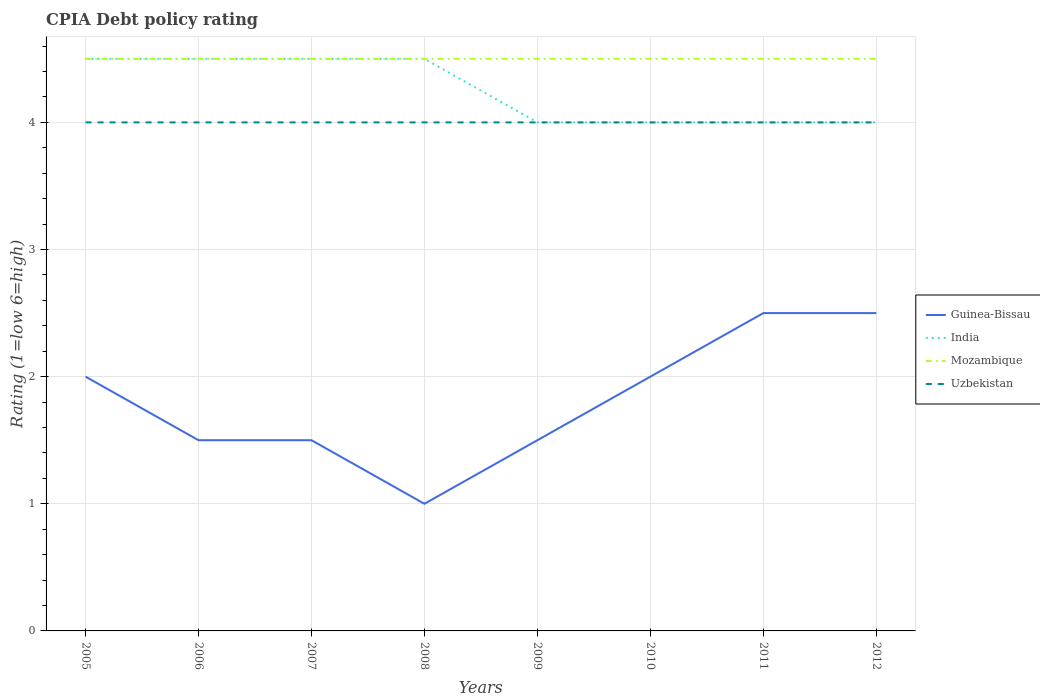Across all years, what is the maximum CPIA rating in Mozambique?
Keep it short and to the point. 4.5. In which year was the CPIA rating in Mozambique maximum?
Provide a succinct answer. 2005. What is the difference between the highest and the lowest CPIA rating in Guinea-Bissau?
Your answer should be compact. 4. Is the CPIA rating in Mozambique strictly greater than the CPIA rating in India over the years?
Your answer should be compact. No. How many lines are there?
Provide a succinct answer. 4. Does the graph contain any zero values?
Offer a very short reply. No. Where does the legend appear in the graph?
Your answer should be compact. Center right. How many legend labels are there?
Keep it short and to the point. 4. How are the legend labels stacked?
Give a very brief answer. Vertical. What is the title of the graph?
Keep it short and to the point. CPIA Debt policy rating. Does "Cuba" appear as one of the legend labels in the graph?
Provide a short and direct response. No. What is the label or title of the X-axis?
Keep it short and to the point. Years. What is the Rating (1=low 6=high) of India in 2005?
Your response must be concise. 4.5. What is the Rating (1=low 6=high) of India in 2007?
Your response must be concise. 4.5. What is the Rating (1=low 6=high) in Guinea-Bissau in 2008?
Make the answer very short. 1. What is the Rating (1=low 6=high) in India in 2008?
Offer a terse response. 4.5. What is the Rating (1=low 6=high) in Uzbekistan in 2008?
Make the answer very short. 4. What is the Rating (1=low 6=high) in India in 2009?
Your response must be concise. 4. What is the Rating (1=low 6=high) in Uzbekistan in 2009?
Provide a succinct answer. 4. What is the Rating (1=low 6=high) of Guinea-Bissau in 2010?
Keep it short and to the point. 2. What is the Rating (1=low 6=high) in India in 2010?
Offer a very short reply. 4. What is the Rating (1=low 6=high) of Uzbekistan in 2010?
Your response must be concise. 4. What is the Rating (1=low 6=high) of Guinea-Bissau in 2012?
Offer a very short reply. 2.5. Across all years, what is the maximum Rating (1=low 6=high) in Guinea-Bissau?
Your response must be concise. 2.5. Across all years, what is the maximum Rating (1=low 6=high) of Mozambique?
Your answer should be very brief. 4.5. Across all years, what is the maximum Rating (1=low 6=high) of Uzbekistan?
Offer a very short reply. 4. Across all years, what is the minimum Rating (1=low 6=high) of Guinea-Bissau?
Provide a short and direct response. 1. Across all years, what is the minimum Rating (1=low 6=high) in Mozambique?
Offer a terse response. 4.5. Across all years, what is the minimum Rating (1=low 6=high) of Uzbekistan?
Provide a short and direct response. 4. What is the total Rating (1=low 6=high) of Uzbekistan in the graph?
Ensure brevity in your answer.  32. What is the difference between the Rating (1=low 6=high) of India in 2005 and that in 2007?
Offer a very short reply. 0. What is the difference between the Rating (1=low 6=high) of Guinea-Bissau in 2005 and that in 2008?
Make the answer very short. 1. What is the difference between the Rating (1=low 6=high) of India in 2005 and that in 2008?
Offer a terse response. 0. What is the difference between the Rating (1=low 6=high) in Uzbekistan in 2005 and that in 2008?
Offer a very short reply. 0. What is the difference between the Rating (1=low 6=high) in Guinea-Bissau in 2005 and that in 2009?
Your answer should be compact. 0.5. What is the difference between the Rating (1=low 6=high) of India in 2005 and that in 2009?
Offer a terse response. 0.5. What is the difference between the Rating (1=low 6=high) in Uzbekistan in 2005 and that in 2009?
Provide a short and direct response. 0. What is the difference between the Rating (1=low 6=high) in Guinea-Bissau in 2005 and that in 2010?
Your response must be concise. 0. What is the difference between the Rating (1=low 6=high) in India in 2005 and that in 2010?
Give a very brief answer. 0.5. What is the difference between the Rating (1=low 6=high) of Uzbekistan in 2005 and that in 2010?
Make the answer very short. 0. What is the difference between the Rating (1=low 6=high) in Guinea-Bissau in 2005 and that in 2011?
Keep it short and to the point. -0.5. What is the difference between the Rating (1=low 6=high) of India in 2005 and that in 2011?
Make the answer very short. 0.5. What is the difference between the Rating (1=low 6=high) in Mozambique in 2005 and that in 2012?
Keep it short and to the point. 0. What is the difference between the Rating (1=low 6=high) in Guinea-Bissau in 2006 and that in 2007?
Ensure brevity in your answer.  0. What is the difference between the Rating (1=low 6=high) in Mozambique in 2006 and that in 2007?
Make the answer very short. 0. What is the difference between the Rating (1=low 6=high) of Guinea-Bissau in 2006 and that in 2008?
Offer a terse response. 0.5. What is the difference between the Rating (1=low 6=high) of Mozambique in 2006 and that in 2008?
Keep it short and to the point. 0. What is the difference between the Rating (1=low 6=high) of India in 2006 and that in 2009?
Your response must be concise. 0.5. What is the difference between the Rating (1=low 6=high) of Guinea-Bissau in 2006 and that in 2010?
Offer a terse response. -0.5. What is the difference between the Rating (1=low 6=high) of Mozambique in 2006 and that in 2010?
Your response must be concise. 0. What is the difference between the Rating (1=low 6=high) of Uzbekistan in 2006 and that in 2010?
Your response must be concise. 0. What is the difference between the Rating (1=low 6=high) in India in 2006 and that in 2011?
Keep it short and to the point. 0.5. What is the difference between the Rating (1=low 6=high) of Guinea-Bissau in 2006 and that in 2012?
Provide a succinct answer. -1. What is the difference between the Rating (1=low 6=high) of India in 2006 and that in 2012?
Provide a succinct answer. 0.5. What is the difference between the Rating (1=low 6=high) of Uzbekistan in 2006 and that in 2012?
Provide a short and direct response. 0. What is the difference between the Rating (1=low 6=high) in Mozambique in 2007 and that in 2008?
Your answer should be very brief. 0. What is the difference between the Rating (1=low 6=high) of Guinea-Bissau in 2007 and that in 2009?
Offer a very short reply. 0. What is the difference between the Rating (1=low 6=high) in India in 2007 and that in 2009?
Your answer should be compact. 0.5. What is the difference between the Rating (1=low 6=high) of Mozambique in 2007 and that in 2009?
Keep it short and to the point. 0. What is the difference between the Rating (1=low 6=high) of Uzbekistan in 2007 and that in 2009?
Ensure brevity in your answer.  0. What is the difference between the Rating (1=low 6=high) of Guinea-Bissau in 2007 and that in 2010?
Your response must be concise. -0.5. What is the difference between the Rating (1=low 6=high) of India in 2007 and that in 2010?
Give a very brief answer. 0.5. What is the difference between the Rating (1=low 6=high) of Uzbekistan in 2007 and that in 2010?
Provide a succinct answer. 0. What is the difference between the Rating (1=low 6=high) of India in 2007 and that in 2011?
Provide a short and direct response. 0.5. What is the difference between the Rating (1=low 6=high) in Guinea-Bissau in 2007 and that in 2012?
Ensure brevity in your answer.  -1. What is the difference between the Rating (1=low 6=high) of Mozambique in 2007 and that in 2012?
Offer a very short reply. 0. What is the difference between the Rating (1=low 6=high) of Uzbekistan in 2007 and that in 2012?
Your answer should be very brief. 0. What is the difference between the Rating (1=low 6=high) of Mozambique in 2008 and that in 2009?
Offer a very short reply. 0. What is the difference between the Rating (1=low 6=high) of India in 2008 and that in 2010?
Give a very brief answer. 0.5. What is the difference between the Rating (1=low 6=high) of Uzbekistan in 2008 and that in 2010?
Provide a succinct answer. 0. What is the difference between the Rating (1=low 6=high) of Guinea-Bissau in 2008 and that in 2011?
Your answer should be compact. -1.5. What is the difference between the Rating (1=low 6=high) of India in 2008 and that in 2011?
Provide a short and direct response. 0.5. What is the difference between the Rating (1=low 6=high) of Uzbekistan in 2008 and that in 2011?
Provide a succinct answer. 0. What is the difference between the Rating (1=low 6=high) in India in 2008 and that in 2012?
Provide a succinct answer. 0.5. What is the difference between the Rating (1=low 6=high) of Mozambique in 2008 and that in 2012?
Your response must be concise. 0. What is the difference between the Rating (1=low 6=high) in Uzbekistan in 2008 and that in 2012?
Your answer should be compact. 0. What is the difference between the Rating (1=low 6=high) of Guinea-Bissau in 2009 and that in 2010?
Your response must be concise. -0.5. What is the difference between the Rating (1=low 6=high) of India in 2009 and that in 2010?
Make the answer very short. 0. What is the difference between the Rating (1=low 6=high) of Mozambique in 2009 and that in 2010?
Provide a short and direct response. 0. What is the difference between the Rating (1=low 6=high) in Uzbekistan in 2009 and that in 2010?
Offer a very short reply. 0. What is the difference between the Rating (1=low 6=high) in Guinea-Bissau in 2009 and that in 2011?
Your response must be concise. -1. What is the difference between the Rating (1=low 6=high) of India in 2009 and that in 2011?
Provide a short and direct response. 0. What is the difference between the Rating (1=low 6=high) in Uzbekistan in 2009 and that in 2011?
Give a very brief answer. 0. What is the difference between the Rating (1=low 6=high) of Guinea-Bissau in 2009 and that in 2012?
Provide a short and direct response. -1. What is the difference between the Rating (1=low 6=high) in Mozambique in 2009 and that in 2012?
Your answer should be compact. 0. What is the difference between the Rating (1=low 6=high) in India in 2010 and that in 2011?
Make the answer very short. 0. What is the difference between the Rating (1=low 6=high) in Mozambique in 2010 and that in 2011?
Offer a very short reply. 0. What is the difference between the Rating (1=low 6=high) in India in 2011 and that in 2012?
Provide a short and direct response. 0. What is the difference between the Rating (1=low 6=high) of Guinea-Bissau in 2005 and the Rating (1=low 6=high) of Mozambique in 2006?
Provide a short and direct response. -2.5. What is the difference between the Rating (1=low 6=high) of Mozambique in 2005 and the Rating (1=low 6=high) of Uzbekistan in 2006?
Give a very brief answer. 0.5. What is the difference between the Rating (1=low 6=high) of Guinea-Bissau in 2005 and the Rating (1=low 6=high) of India in 2007?
Your answer should be compact. -2.5. What is the difference between the Rating (1=low 6=high) in Guinea-Bissau in 2005 and the Rating (1=low 6=high) in Uzbekistan in 2007?
Keep it short and to the point. -2. What is the difference between the Rating (1=low 6=high) of India in 2005 and the Rating (1=low 6=high) of Uzbekistan in 2007?
Give a very brief answer. 0.5. What is the difference between the Rating (1=low 6=high) of Guinea-Bissau in 2005 and the Rating (1=low 6=high) of India in 2008?
Offer a very short reply. -2.5. What is the difference between the Rating (1=low 6=high) in Guinea-Bissau in 2005 and the Rating (1=low 6=high) in Mozambique in 2008?
Provide a succinct answer. -2.5. What is the difference between the Rating (1=low 6=high) in India in 2005 and the Rating (1=low 6=high) in Mozambique in 2008?
Your response must be concise. 0. What is the difference between the Rating (1=low 6=high) of India in 2005 and the Rating (1=low 6=high) of Uzbekistan in 2008?
Make the answer very short. 0.5. What is the difference between the Rating (1=low 6=high) of Guinea-Bissau in 2005 and the Rating (1=low 6=high) of India in 2009?
Provide a short and direct response. -2. What is the difference between the Rating (1=low 6=high) in Guinea-Bissau in 2005 and the Rating (1=low 6=high) in Uzbekistan in 2009?
Provide a short and direct response. -2. What is the difference between the Rating (1=low 6=high) in Guinea-Bissau in 2005 and the Rating (1=low 6=high) in India in 2010?
Offer a terse response. -2. What is the difference between the Rating (1=low 6=high) in Guinea-Bissau in 2005 and the Rating (1=low 6=high) in Mozambique in 2010?
Your response must be concise. -2.5. What is the difference between the Rating (1=low 6=high) in India in 2005 and the Rating (1=low 6=high) in Uzbekistan in 2010?
Your answer should be compact. 0.5. What is the difference between the Rating (1=low 6=high) in Guinea-Bissau in 2005 and the Rating (1=low 6=high) in India in 2011?
Offer a terse response. -2. What is the difference between the Rating (1=low 6=high) in India in 2005 and the Rating (1=low 6=high) in Uzbekistan in 2011?
Provide a short and direct response. 0.5. What is the difference between the Rating (1=low 6=high) of Mozambique in 2005 and the Rating (1=low 6=high) of Uzbekistan in 2011?
Offer a terse response. 0.5. What is the difference between the Rating (1=low 6=high) in Guinea-Bissau in 2005 and the Rating (1=low 6=high) in Mozambique in 2012?
Your response must be concise. -2.5. What is the difference between the Rating (1=low 6=high) in Mozambique in 2005 and the Rating (1=low 6=high) in Uzbekistan in 2012?
Your answer should be compact. 0.5. What is the difference between the Rating (1=low 6=high) of Guinea-Bissau in 2006 and the Rating (1=low 6=high) of Uzbekistan in 2007?
Ensure brevity in your answer.  -2.5. What is the difference between the Rating (1=low 6=high) of Mozambique in 2006 and the Rating (1=low 6=high) of Uzbekistan in 2007?
Provide a short and direct response. 0.5. What is the difference between the Rating (1=low 6=high) in Guinea-Bissau in 2006 and the Rating (1=low 6=high) in India in 2008?
Give a very brief answer. -3. What is the difference between the Rating (1=low 6=high) in Guinea-Bissau in 2006 and the Rating (1=low 6=high) in Mozambique in 2008?
Ensure brevity in your answer.  -3. What is the difference between the Rating (1=low 6=high) in Mozambique in 2006 and the Rating (1=low 6=high) in Uzbekistan in 2008?
Give a very brief answer. 0.5. What is the difference between the Rating (1=low 6=high) of Guinea-Bissau in 2006 and the Rating (1=low 6=high) of India in 2009?
Keep it short and to the point. -2.5. What is the difference between the Rating (1=low 6=high) of Guinea-Bissau in 2006 and the Rating (1=low 6=high) of Uzbekistan in 2009?
Your response must be concise. -2.5. What is the difference between the Rating (1=low 6=high) of India in 2006 and the Rating (1=low 6=high) of Mozambique in 2009?
Offer a very short reply. 0. What is the difference between the Rating (1=low 6=high) in Guinea-Bissau in 2006 and the Rating (1=low 6=high) in Mozambique in 2010?
Offer a terse response. -3. What is the difference between the Rating (1=low 6=high) of Guinea-Bissau in 2006 and the Rating (1=low 6=high) of Uzbekistan in 2010?
Provide a short and direct response. -2.5. What is the difference between the Rating (1=low 6=high) of India in 2006 and the Rating (1=low 6=high) of Mozambique in 2010?
Provide a short and direct response. 0. What is the difference between the Rating (1=low 6=high) of Mozambique in 2006 and the Rating (1=low 6=high) of Uzbekistan in 2010?
Provide a short and direct response. 0.5. What is the difference between the Rating (1=low 6=high) in Guinea-Bissau in 2006 and the Rating (1=low 6=high) in India in 2011?
Your response must be concise. -2.5. What is the difference between the Rating (1=low 6=high) in India in 2006 and the Rating (1=low 6=high) in Uzbekistan in 2011?
Your answer should be very brief. 0.5. What is the difference between the Rating (1=low 6=high) of Mozambique in 2006 and the Rating (1=low 6=high) of Uzbekistan in 2011?
Provide a short and direct response. 0.5. What is the difference between the Rating (1=low 6=high) of Guinea-Bissau in 2006 and the Rating (1=low 6=high) of Mozambique in 2012?
Provide a succinct answer. -3. What is the difference between the Rating (1=low 6=high) in Guinea-Bissau in 2006 and the Rating (1=low 6=high) in Uzbekistan in 2012?
Provide a succinct answer. -2.5. What is the difference between the Rating (1=low 6=high) of Mozambique in 2006 and the Rating (1=low 6=high) of Uzbekistan in 2012?
Give a very brief answer. 0.5. What is the difference between the Rating (1=low 6=high) in Guinea-Bissau in 2007 and the Rating (1=low 6=high) in India in 2008?
Your answer should be very brief. -3. What is the difference between the Rating (1=low 6=high) in Guinea-Bissau in 2007 and the Rating (1=low 6=high) in Uzbekistan in 2008?
Provide a succinct answer. -2.5. What is the difference between the Rating (1=low 6=high) of India in 2007 and the Rating (1=low 6=high) of Mozambique in 2008?
Your response must be concise. 0. What is the difference between the Rating (1=low 6=high) of Guinea-Bissau in 2007 and the Rating (1=low 6=high) of Mozambique in 2009?
Your answer should be compact. -3. What is the difference between the Rating (1=low 6=high) in India in 2007 and the Rating (1=low 6=high) in Uzbekistan in 2009?
Provide a short and direct response. 0.5. What is the difference between the Rating (1=low 6=high) in Guinea-Bissau in 2007 and the Rating (1=low 6=high) in India in 2010?
Ensure brevity in your answer.  -2.5. What is the difference between the Rating (1=low 6=high) of India in 2007 and the Rating (1=low 6=high) of Mozambique in 2010?
Offer a terse response. 0. What is the difference between the Rating (1=low 6=high) of India in 2007 and the Rating (1=low 6=high) of Uzbekistan in 2010?
Your response must be concise. 0.5. What is the difference between the Rating (1=low 6=high) of Mozambique in 2007 and the Rating (1=low 6=high) of Uzbekistan in 2010?
Make the answer very short. 0.5. What is the difference between the Rating (1=low 6=high) of India in 2007 and the Rating (1=low 6=high) of Mozambique in 2011?
Ensure brevity in your answer.  0. What is the difference between the Rating (1=low 6=high) in Mozambique in 2007 and the Rating (1=low 6=high) in Uzbekistan in 2011?
Keep it short and to the point. 0.5. What is the difference between the Rating (1=low 6=high) of Guinea-Bissau in 2007 and the Rating (1=low 6=high) of Uzbekistan in 2012?
Provide a short and direct response. -2.5. What is the difference between the Rating (1=low 6=high) in India in 2007 and the Rating (1=low 6=high) in Mozambique in 2012?
Your response must be concise. 0. What is the difference between the Rating (1=low 6=high) of Mozambique in 2007 and the Rating (1=low 6=high) of Uzbekistan in 2012?
Your response must be concise. 0.5. What is the difference between the Rating (1=low 6=high) in Guinea-Bissau in 2008 and the Rating (1=low 6=high) in Uzbekistan in 2009?
Your answer should be very brief. -3. What is the difference between the Rating (1=low 6=high) of India in 2008 and the Rating (1=low 6=high) of Uzbekistan in 2009?
Your answer should be compact. 0.5. What is the difference between the Rating (1=low 6=high) of Mozambique in 2008 and the Rating (1=low 6=high) of Uzbekistan in 2009?
Ensure brevity in your answer.  0.5. What is the difference between the Rating (1=low 6=high) of Guinea-Bissau in 2008 and the Rating (1=low 6=high) of India in 2010?
Your answer should be compact. -3. What is the difference between the Rating (1=low 6=high) in Guinea-Bissau in 2008 and the Rating (1=low 6=high) in Uzbekistan in 2010?
Make the answer very short. -3. What is the difference between the Rating (1=low 6=high) in India in 2008 and the Rating (1=low 6=high) in Mozambique in 2010?
Provide a short and direct response. 0. What is the difference between the Rating (1=low 6=high) in India in 2008 and the Rating (1=low 6=high) in Uzbekistan in 2010?
Provide a succinct answer. 0.5. What is the difference between the Rating (1=low 6=high) of Guinea-Bissau in 2008 and the Rating (1=low 6=high) of Uzbekistan in 2011?
Make the answer very short. -3. What is the difference between the Rating (1=low 6=high) in India in 2008 and the Rating (1=low 6=high) in Uzbekistan in 2011?
Offer a terse response. 0.5. What is the difference between the Rating (1=low 6=high) of Mozambique in 2008 and the Rating (1=low 6=high) of Uzbekistan in 2011?
Give a very brief answer. 0.5. What is the difference between the Rating (1=low 6=high) in Guinea-Bissau in 2008 and the Rating (1=low 6=high) in India in 2012?
Keep it short and to the point. -3. What is the difference between the Rating (1=low 6=high) in India in 2008 and the Rating (1=low 6=high) in Uzbekistan in 2012?
Keep it short and to the point. 0.5. What is the difference between the Rating (1=low 6=high) of Mozambique in 2008 and the Rating (1=low 6=high) of Uzbekistan in 2012?
Provide a succinct answer. 0.5. What is the difference between the Rating (1=low 6=high) of Guinea-Bissau in 2009 and the Rating (1=low 6=high) of India in 2010?
Make the answer very short. -2.5. What is the difference between the Rating (1=low 6=high) in Guinea-Bissau in 2009 and the Rating (1=low 6=high) in Mozambique in 2010?
Give a very brief answer. -3. What is the difference between the Rating (1=low 6=high) of Guinea-Bissau in 2009 and the Rating (1=low 6=high) of Uzbekistan in 2010?
Your answer should be compact. -2.5. What is the difference between the Rating (1=low 6=high) of Guinea-Bissau in 2009 and the Rating (1=low 6=high) of Mozambique in 2011?
Offer a terse response. -3. What is the difference between the Rating (1=low 6=high) of India in 2009 and the Rating (1=low 6=high) of Mozambique in 2011?
Offer a terse response. -0.5. What is the difference between the Rating (1=low 6=high) of India in 2009 and the Rating (1=low 6=high) of Uzbekistan in 2011?
Make the answer very short. 0. What is the difference between the Rating (1=low 6=high) of Guinea-Bissau in 2009 and the Rating (1=low 6=high) of India in 2012?
Ensure brevity in your answer.  -2.5. What is the difference between the Rating (1=low 6=high) in Guinea-Bissau in 2009 and the Rating (1=low 6=high) in Uzbekistan in 2012?
Ensure brevity in your answer.  -2.5. What is the difference between the Rating (1=low 6=high) in India in 2009 and the Rating (1=low 6=high) in Mozambique in 2012?
Offer a terse response. -0.5. What is the difference between the Rating (1=low 6=high) in India in 2010 and the Rating (1=low 6=high) in Mozambique in 2011?
Make the answer very short. -0.5. What is the difference between the Rating (1=low 6=high) in Mozambique in 2010 and the Rating (1=low 6=high) in Uzbekistan in 2011?
Offer a very short reply. 0.5. What is the difference between the Rating (1=low 6=high) in Guinea-Bissau in 2010 and the Rating (1=low 6=high) in Mozambique in 2012?
Offer a very short reply. -2.5. What is the difference between the Rating (1=low 6=high) of Mozambique in 2010 and the Rating (1=low 6=high) of Uzbekistan in 2012?
Offer a very short reply. 0.5. What is the difference between the Rating (1=low 6=high) in Guinea-Bissau in 2011 and the Rating (1=low 6=high) in Mozambique in 2012?
Your response must be concise. -2. What is the difference between the Rating (1=low 6=high) in Mozambique in 2011 and the Rating (1=low 6=high) in Uzbekistan in 2012?
Give a very brief answer. 0.5. What is the average Rating (1=low 6=high) of Guinea-Bissau per year?
Make the answer very short. 1.81. What is the average Rating (1=low 6=high) of India per year?
Ensure brevity in your answer.  4.25. In the year 2005, what is the difference between the Rating (1=low 6=high) of Guinea-Bissau and Rating (1=low 6=high) of India?
Your response must be concise. -2.5. In the year 2005, what is the difference between the Rating (1=low 6=high) of Guinea-Bissau and Rating (1=low 6=high) of Mozambique?
Give a very brief answer. -2.5. In the year 2005, what is the difference between the Rating (1=low 6=high) of Guinea-Bissau and Rating (1=low 6=high) of Uzbekistan?
Provide a succinct answer. -2. In the year 2005, what is the difference between the Rating (1=low 6=high) in India and Rating (1=low 6=high) in Uzbekistan?
Make the answer very short. 0.5. In the year 2005, what is the difference between the Rating (1=low 6=high) in Mozambique and Rating (1=low 6=high) in Uzbekistan?
Keep it short and to the point. 0.5. In the year 2006, what is the difference between the Rating (1=low 6=high) in Guinea-Bissau and Rating (1=low 6=high) in Mozambique?
Your response must be concise. -3. In the year 2006, what is the difference between the Rating (1=low 6=high) in India and Rating (1=low 6=high) in Uzbekistan?
Provide a succinct answer. 0.5. In the year 2006, what is the difference between the Rating (1=low 6=high) in Mozambique and Rating (1=low 6=high) in Uzbekistan?
Provide a short and direct response. 0.5. In the year 2007, what is the difference between the Rating (1=low 6=high) of Mozambique and Rating (1=low 6=high) of Uzbekistan?
Your response must be concise. 0.5. In the year 2008, what is the difference between the Rating (1=low 6=high) of India and Rating (1=low 6=high) of Uzbekistan?
Make the answer very short. 0.5. In the year 2009, what is the difference between the Rating (1=low 6=high) of India and Rating (1=low 6=high) of Uzbekistan?
Your answer should be compact. 0. In the year 2010, what is the difference between the Rating (1=low 6=high) in Guinea-Bissau and Rating (1=low 6=high) in India?
Make the answer very short. -2. In the year 2010, what is the difference between the Rating (1=low 6=high) of Guinea-Bissau and Rating (1=low 6=high) of Mozambique?
Your response must be concise. -2.5. In the year 2010, what is the difference between the Rating (1=low 6=high) of Guinea-Bissau and Rating (1=low 6=high) of Uzbekistan?
Offer a very short reply. -2. In the year 2010, what is the difference between the Rating (1=low 6=high) of India and Rating (1=low 6=high) of Mozambique?
Keep it short and to the point. -0.5. In the year 2011, what is the difference between the Rating (1=low 6=high) in Guinea-Bissau and Rating (1=low 6=high) in India?
Ensure brevity in your answer.  -1.5. In the year 2011, what is the difference between the Rating (1=low 6=high) in Guinea-Bissau and Rating (1=low 6=high) in Mozambique?
Ensure brevity in your answer.  -2. In the year 2011, what is the difference between the Rating (1=low 6=high) of India and Rating (1=low 6=high) of Mozambique?
Offer a terse response. -0.5. In the year 2011, what is the difference between the Rating (1=low 6=high) of India and Rating (1=low 6=high) of Uzbekistan?
Your answer should be compact. 0. In the year 2012, what is the difference between the Rating (1=low 6=high) of Guinea-Bissau and Rating (1=low 6=high) of India?
Ensure brevity in your answer.  -1.5. In the year 2012, what is the difference between the Rating (1=low 6=high) in Guinea-Bissau and Rating (1=low 6=high) in Uzbekistan?
Your response must be concise. -1.5. In the year 2012, what is the difference between the Rating (1=low 6=high) of India and Rating (1=low 6=high) of Mozambique?
Provide a short and direct response. -0.5. In the year 2012, what is the difference between the Rating (1=low 6=high) of India and Rating (1=low 6=high) of Uzbekistan?
Provide a short and direct response. 0. In the year 2012, what is the difference between the Rating (1=low 6=high) of Mozambique and Rating (1=low 6=high) of Uzbekistan?
Your response must be concise. 0.5. What is the ratio of the Rating (1=low 6=high) in India in 2005 to that in 2006?
Your answer should be compact. 1. What is the ratio of the Rating (1=low 6=high) in Uzbekistan in 2005 to that in 2006?
Give a very brief answer. 1. What is the ratio of the Rating (1=low 6=high) in Guinea-Bissau in 2005 to that in 2007?
Ensure brevity in your answer.  1.33. What is the ratio of the Rating (1=low 6=high) in India in 2005 to that in 2007?
Your response must be concise. 1. What is the ratio of the Rating (1=low 6=high) in Mozambique in 2005 to that in 2007?
Offer a very short reply. 1. What is the ratio of the Rating (1=low 6=high) in Guinea-Bissau in 2005 to that in 2008?
Give a very brief answer. 2. What is the ratio of the Rating (1=low 6=high) of Mozambique in 2005 to that in 2008?
Provide a short and direct response. 1. What is the ratio of the Rating (1=low 6=high) in India in 2005 to that in 2009?
Your answer should be compact. 1.12. What is the ratio of the Rating (1=low 6=high) in Uzbekistan in 2005 to that in 2009?
Provide a succinct answer. 1. What is the ratio of the Rating (1=low 6=high) of Guinea-Bissau in 2005 to that in 2010?
Give a very brief answer. 1. What is the ratio of the Rating (1=low 6=high) in Mozambique in 2005 to that in 2010?
Offer a very short reply. 1. What is the ratio of the Rating (1=low 6=high) in Guinea-Bissau in 2005 to that in 2011?
Make the answer very short. 0.8. What is the ratio of the Rating (1=low 6=high) in India in 2005 to that in 2011?
Your answer should be very brief. 1.12. What is the ratio of the Rating (1=low 6=high) in Mozambique in 2005 to that in 2011?
Offer a terse response. 1. What is the ratio of the Rating (1=low 6=high) of Uzbekistan in 2005 to that in 2011?
Your answer should be very brief. 1. What is the ratio of the Rating (1=low 6=high) in India in 2005 to that in 2012?
Keep it short and to the point. 1.12. What is the ratio of the Rating (1=low 6=high) in Uzbekistan in 2005 to that in 2012?
Your answer should be very brief. 1. What is the ratio of the Rating (1=low 6=high) in Mozambique in 2006 to that in 2008?
Your answer should be compact. 1. What is the ratio of the Rating (1=low 6=high) of Guinea-Bissau in 2006 to that in 2009?
Keep it short and to the point. 1. What is the ratio of the Rating (1=low 6=high) of Mozambique in 2006 to that in 2009?
Your answer should be compact. 1. What is the ratio of the Rating (1=low 6=high) in Uzbekistan in 2006 to that in 2009?
Give a very brief answer. 1. What is the ratio of the Rating (1=low 6=high) in Guinea-Bissau in 2006 to that in 2010?
Your answer should be compact. 0.75. What is the ratio of the Rating (1=low 6=high) of Mozambique in 2006 to that in 2010?
Keep it short and to the point. 1. What is the ratio of the Rating (1=low 6=high) of Uzbekistan in 2006 to that in 2010?
Your response must be concise. 1. What is the ratio of the Rating (1=low 6=high) in India in 2006 to that in 2011?
Offer a very short reply. 1.12. What is the ratio of the Rating (1=low 6=high) of Guinea-Bissau in 2006 to that in 2012?
Make the answer very short. 0.6. What is the ratio of the Rating (1=low 6=high) of India in 2006 to that in 2012?
Ensure brevity in your answer.  1.12. What is the ratio of the Rating (1=low 6=high) of Mozambique in 2006 to that in 2012?
Offer a terse response. 1. What is the ratio of the Rating (1=low 6=high) in Guinea-Bissau in 2007 to that in 2008?
Your response must be concise. 1.5. What is the ratio of the Rating (1=low 6=high) in Uzbekistan in 2007 to that in 2008?
Keep it short and to the point. 1. What is the ratio of the Rating (1=low 6=high) in India in 2007 to that in 2009?
Keep it short and to the point. 1.12. What is the ratio of the Rating (1=low 6=high) of India in 2007 to that in 2010?
Provide a succinct answer. 1.12. What is the ratio of the Rating (1=low 6=high) in Mozambique in 2007 to that in 2010?
Your response must be concise. 1. What is the ratio of the Rating (1=low 6=high) in Guinea-Bissau in 2007 to that in 2011?
Offer a terse response. 0.6. What is the ratio of the Rating (1=low 6=high) in India in 2007 to that in 2011?
Keep it short and to the point. 1.12. What is the ratio of the Rating (1=low 6=high) of Guinea-Bissau in 2007 to that in 2012?
Your answer should be compact. 0.6. What is the ratio of the Rating (1=low 6=high) in India in 2007 to that in 2012?
Make the answer very short. 1.12. What is the ratio of the Rating (1=low 6=high) in Uzbekistan in 2008 to that in 2009?
Give a very brief answer. 1. What is the ratio of the Rating (1=low 6=high) of Guinea-Bissau in 2008 to that in 2010?
Provide a short and direct response. 0.5. What is the ratio of the Rating (1=low 6=high) of Mozambique in 2008 to that in 2010?
Provide a short and direct response. 1. What is the ratio of the Rating (1=low 6=high) of Uzbekistan in 2008 to that in 2010?
Provide a succinct answer. 1. What is the ratio of the Rating (1=low 6=high) in Guinea-Bissau in 2008 to that in 2011?
Your answer should be very brief. 0.4. What is the ratio of the Rating (1=low 6=high) of Uzbekistan in 2008 to that in 2011?
Give a very brief answer. 1. What is the ratio of the Rating (1=low 6=high) in India in 2008 to that in 2012?
Your answer should be very brief. 1.12. What is the ratio of the Rating (1=low 6=high) of Uzbekistan in 2008 to that in 2012?
Ensure brevity in your answer.  1. What is the ratio of the Rating (1=low 6=high) of India in 2009 to that in 2010?
Give a very brief answer. 1. What is the ratio of the Rating (1=low 6=high) in Uzbekistan in 2009 to that in 2010?
Keep it short and to the point. 1. What is the ratio of the Rating (1=low 6=high) in Guinea-Bissau in 2009 to that in 2011?
Give a very brief answer. 0.6. What is the ratio of the Rating (1=low 6=high) of India in 2009 to that in 2011?
Offer a terse response. 1. What is the ratio of the Rating (1=low 6=high) of India in 2009 to that in 2012?
Provide a short and direct response. 1. What is the ratio of the Rating (1=low 6=high) of Mozambique in 2009 to that in 2012?
Provide a short and direct response. 1. What is the ratio of the Rating (1=low 6=high) of Uzbekistan in 2009 to that in 2012?
Your response must be concise. 1. What is the ratio of the Rating (1=low 6=high) in India in 2010 to that in 2011?
Provide a succinct answer. 1. What is the ratio of the Rating (1=low 6=high) in Mozambique in 2010 to that in 2011?
Offer a very short reply. 1. What is the ratio of the Rating (1=low 6=high) of Guinea-Bissau in 2010 to that in 2012?
Give a very brief answer. 0.8. What is the ratio of the Rating (1=low 6=high) of India in 2010 to that in 2012?
Give a very brief answer. 1. What is the ratio of the Rating (1=low 6=high) in Uzbekistan in 2010 to that in 2012?
Offer a very short reply. 1. What is the ratio of the Rating (1=low 6=high) in India in 2011 to that in 2012?
Give a very brief answer. 1. What is the ratio of the Rating (1=low 6=high) of Uzbekistan in 2011 to that in 2012?
Give a very brief answer. 1. What is the difference between the highest and the second highest Rating (1=low 6=high) in Mozambique?
Offer a very short reply. 0. What is the difference between the highest and the second highest Rating (1=low 6=high) of Uzbekistan?
Your answer should be compact. 0. What is the difference between the highest and the lowest Rating (1=low 6=high) of India?
Your answer should be very brief. 0.5. What is the difference between the highest and the lowest Rating (1=low 6=high) in Mozambique?
Keep it short and to the point. 0. What is the difference between the highest and the lowest Rating (1=low 6=high) of Uzbekistan?
Give a very brief answer. 0. 